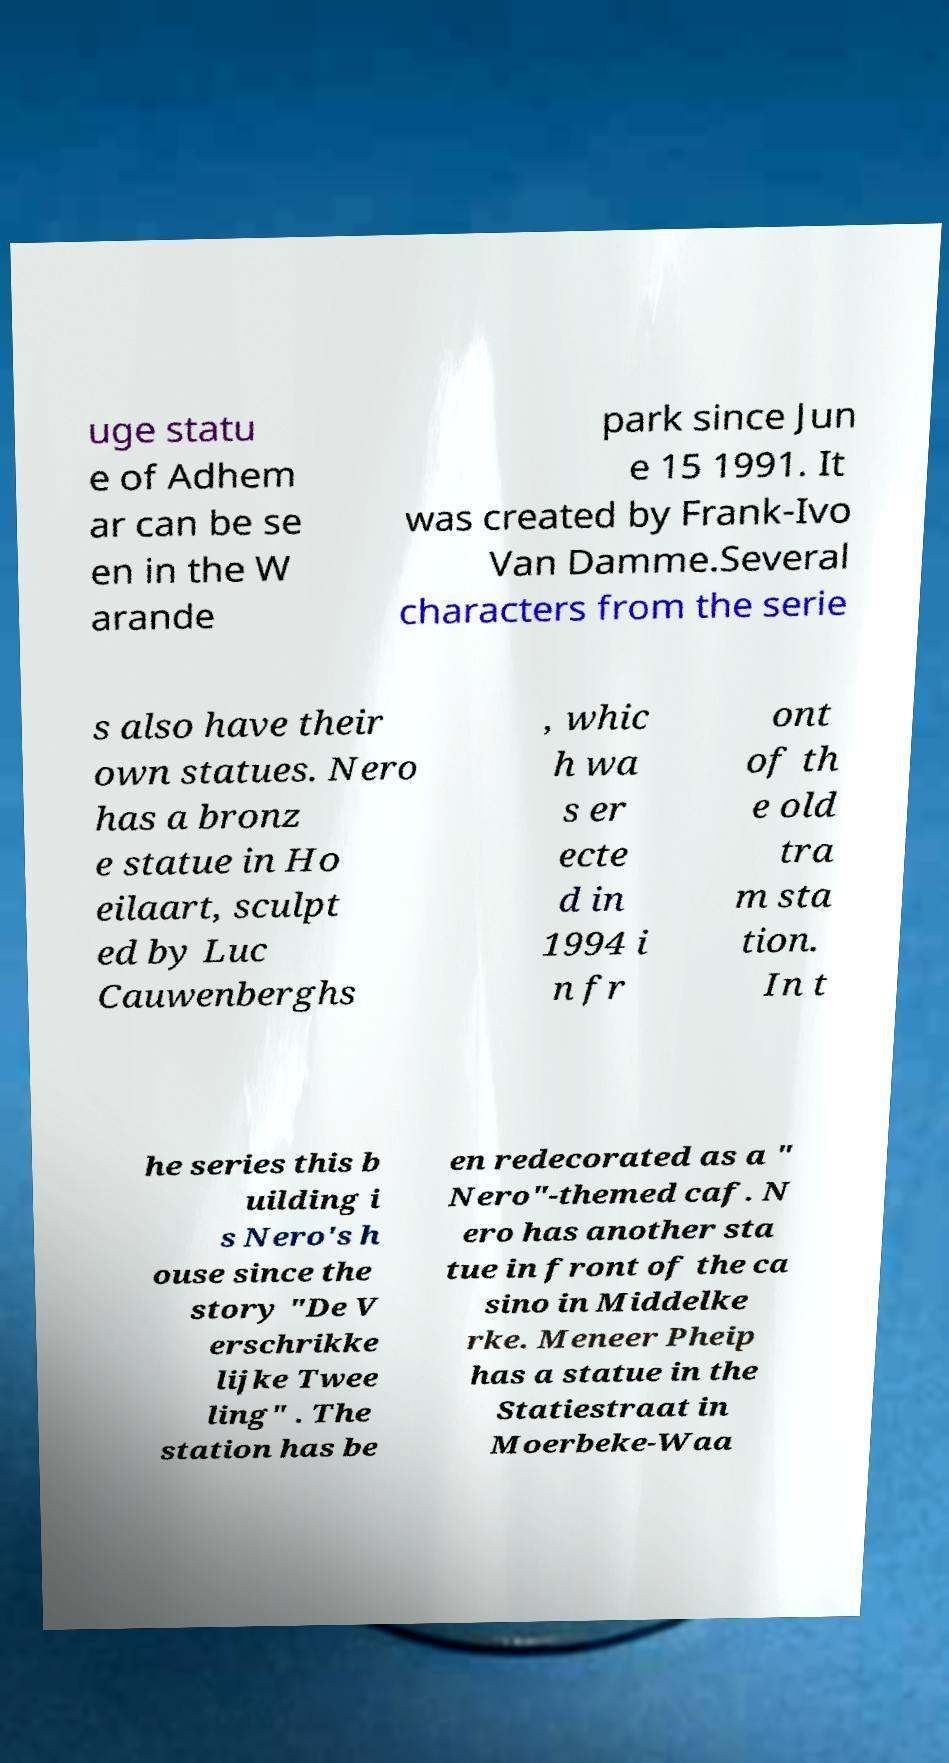What messages or text are displayed in this image? I need them in a readable, typed format. uge statu e of Adhem ar can be se en in the W arande park since Jun e 15 1991. It was created by Frank-Ivo Van Damme.Several characters from the serie s also have their own statues. Nero has a bronz e statue in Ho eilaart, sculpt ed by Luc Cauwenberghs , whic h wa s er ecte d in 1994 i n fr ont of th e old tra m sta tion. In t he series this b uilding i s Nero's h ouse since the story "De V erschrikke lijke Twee ling" . The station has be en redecorated as a " Nero"-themed caf. N ero has another sta tue in front of the ca sino in Middelke rke. Meneer Pheip has a statue in the Statiestraat in Moerbeke-Waa 